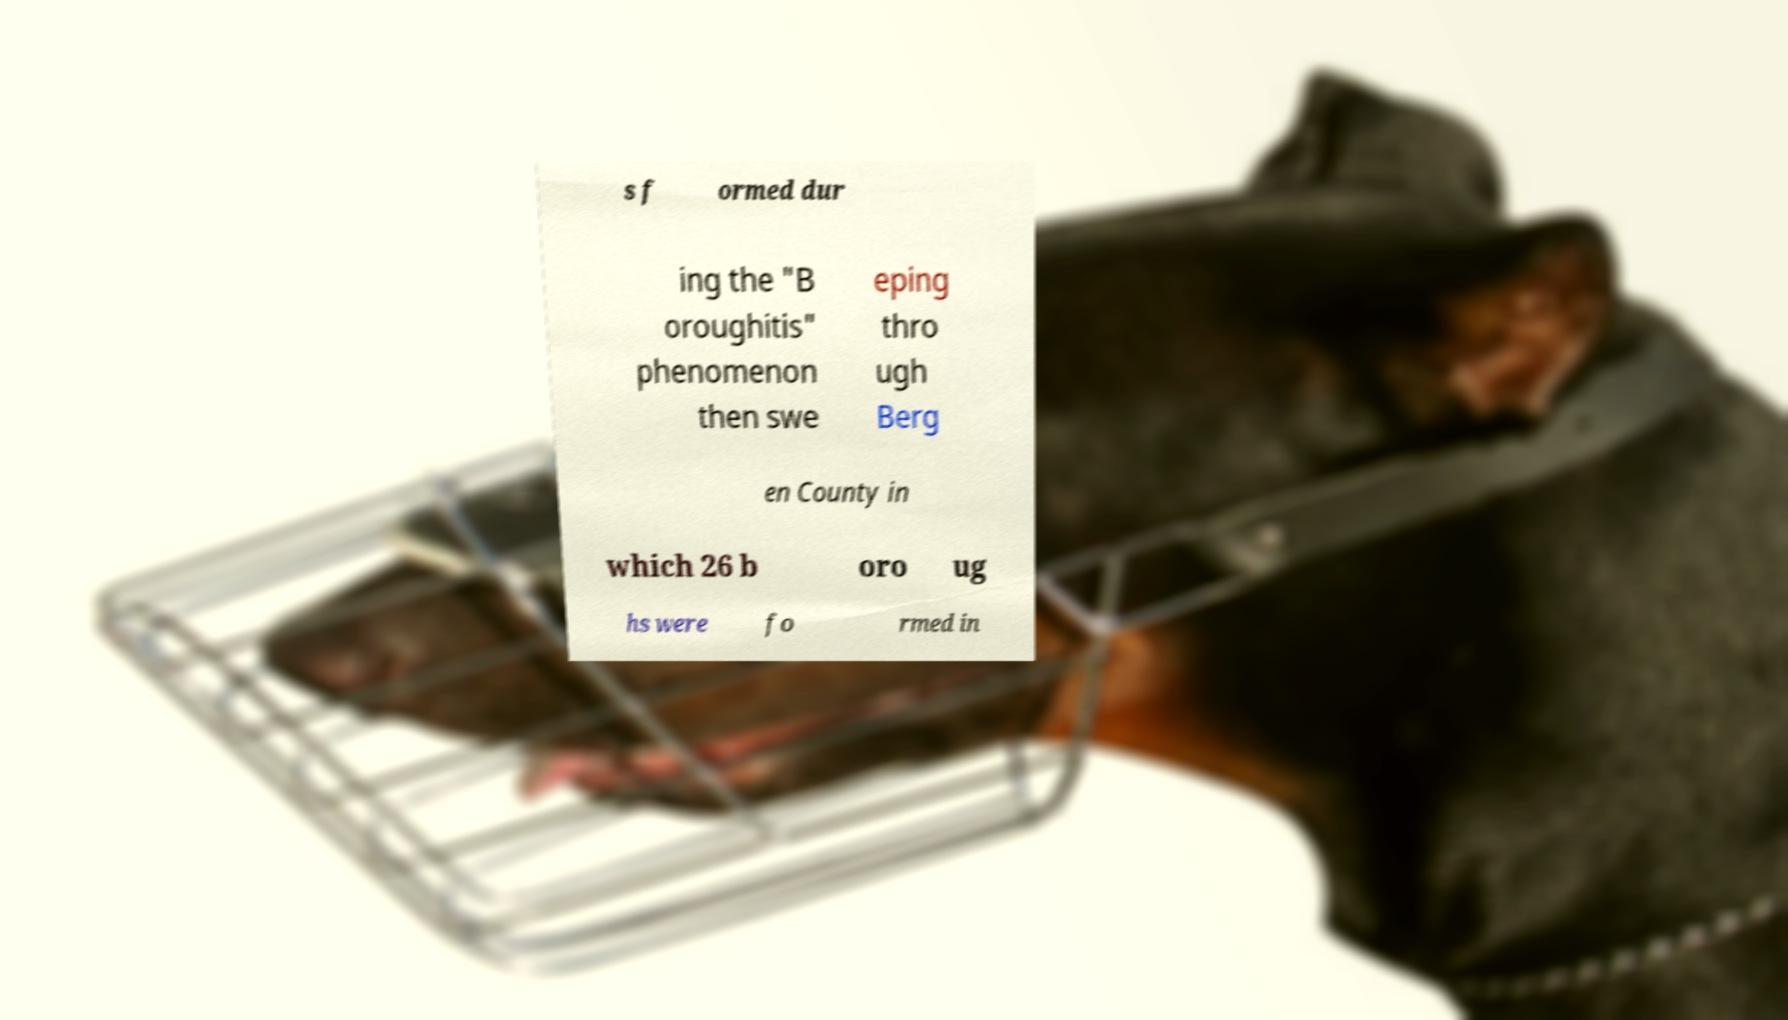What messages or text are displayed in this image? I need them in a readable, typed format. s f ormed dur ing the "B oroughitis" phenomenon then swe eping thro ugh Berg en County in which 26 b oro ug hs were fo rmed in 